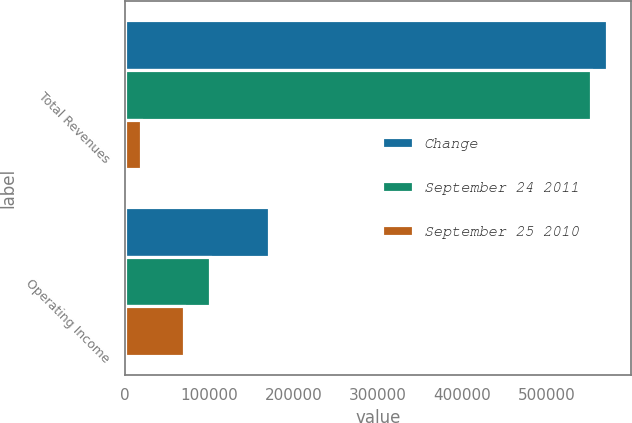Convert chart to OTSL. <chart><loc_0><loc_0><loc_500><loc_500><stacked_bar_chart><ecel><fcel>Total Revenues<fcel>Operating Income<nl><fcel>Change<fcel>571263<fcel>170693<nl><fcel>September 24 2011<fcel>552501<fcel>100469<nl><fcel>September 25 2010<fcel>18762<fcel>70224<nl></chart> 